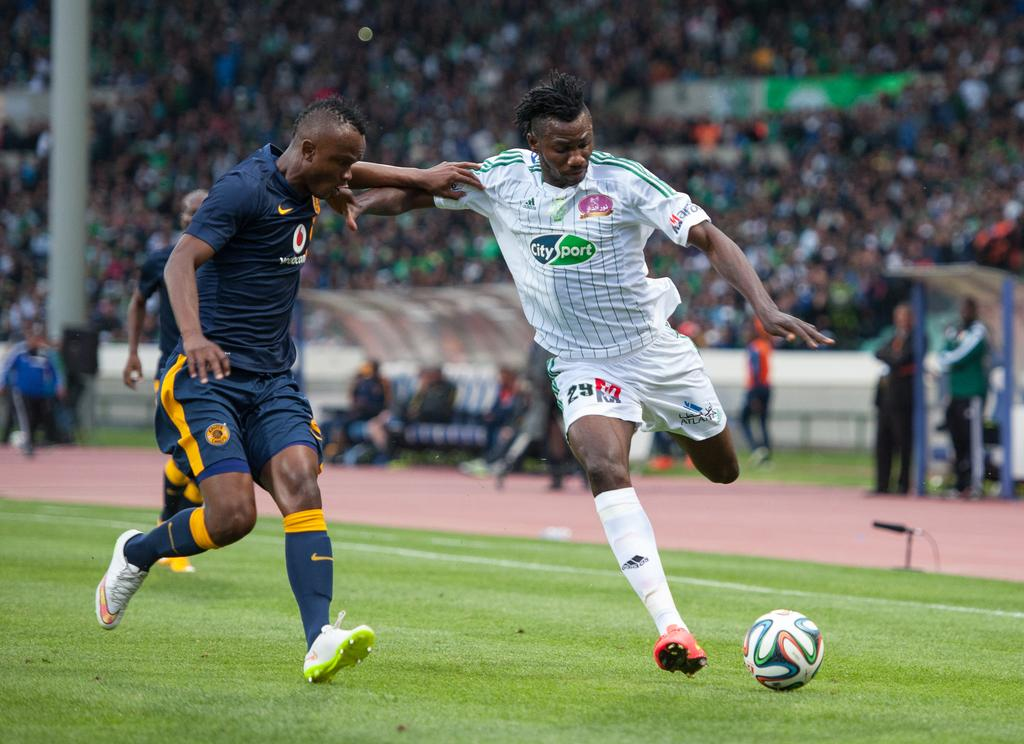How many players are involved in the game in the image? There are two players in the image. What are the players doing in the image? The players are running in the image. What are the players chasing in the image? The players are chasing a football in the image. What is the position of the football in the image? The football is on the ground in the image. What can be observed about the spectators in the background? There are people sitting and watching the game in the background. What type of parcel is being delivered to the player's stomach in the image? There is no parcel or reference to a player's stomach in the image; it features two players chasing a football. 